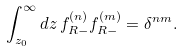<formula> <loc_0><loc_0><loc_500><loc_500>\int _ { z _ { 0 } } ^ { \infty } d z \, f _ { R - } ^ { ( n ) } f _ { R - } ^ { ( m ) } = \delta ^ { n m } .</formula> 